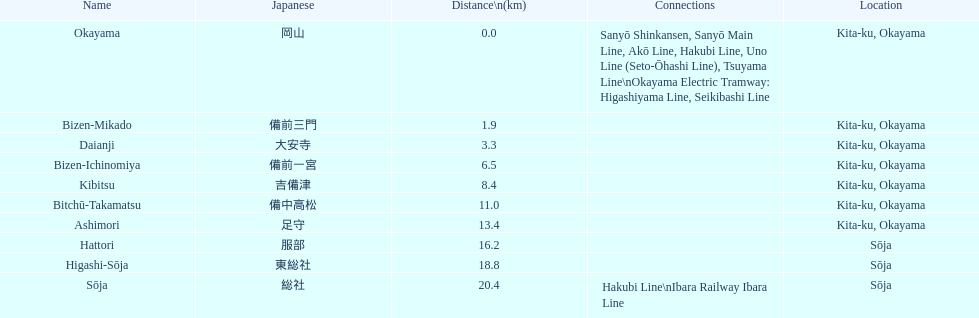Can you list the stations that serve as transfer points between lines? Okayama, Sōja. 